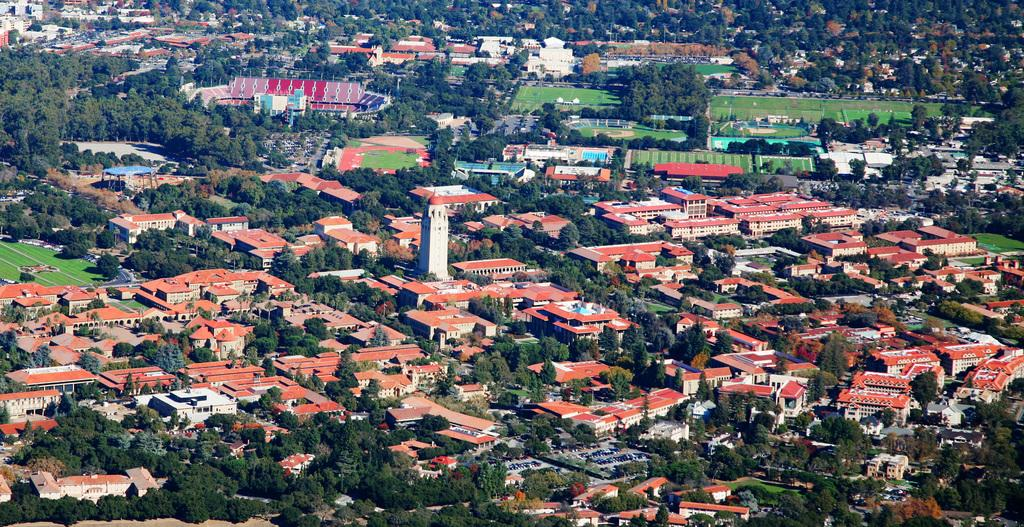What type of structures can be seen in the image? There is a group of houses and buildings in the image. Can you describe the natural elements present in the image? There are trees visible in the background of the image. What type of shoes can be seen hanging from the trees in the image? There are no shoes present in the image; only houses, buildings, and trees can be seen. 